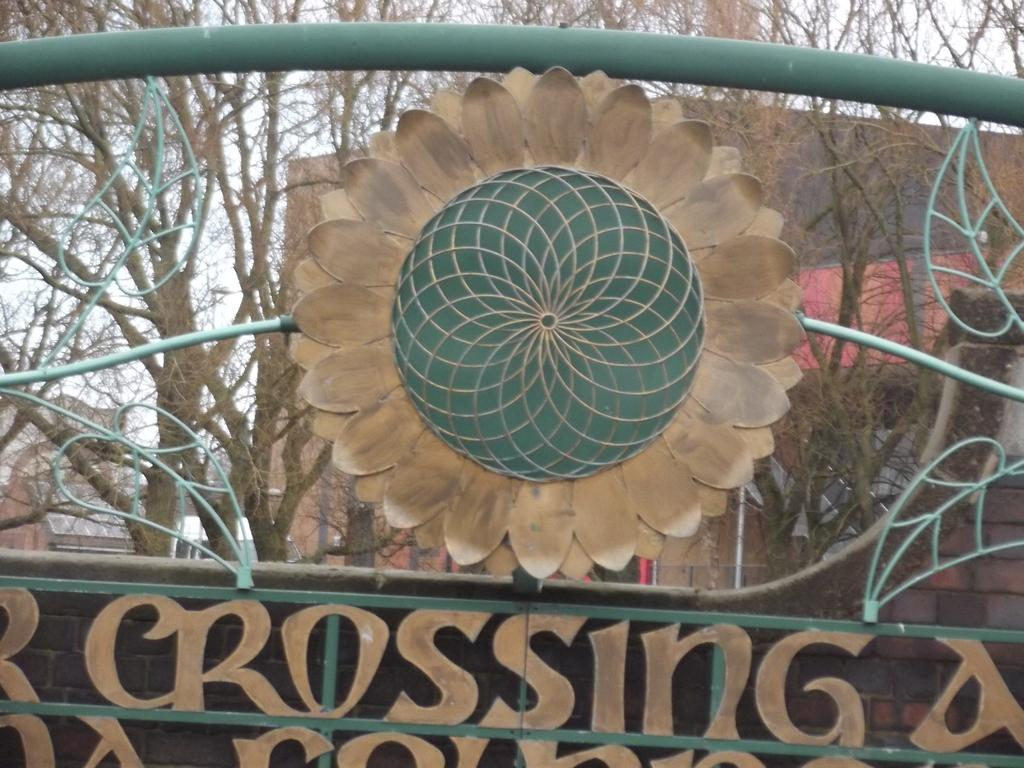What type of object is present in the image that is made of metal? There is a metal object in the image. What colors can be seen on the metal object? The metal object has green and brown colors. What can be seen in the background of the image? There are many trees and buildings in the background of the image, as well as the sky. What type of furniture is being blown by the wind in the image? There is no furniture or wind present in the image. 